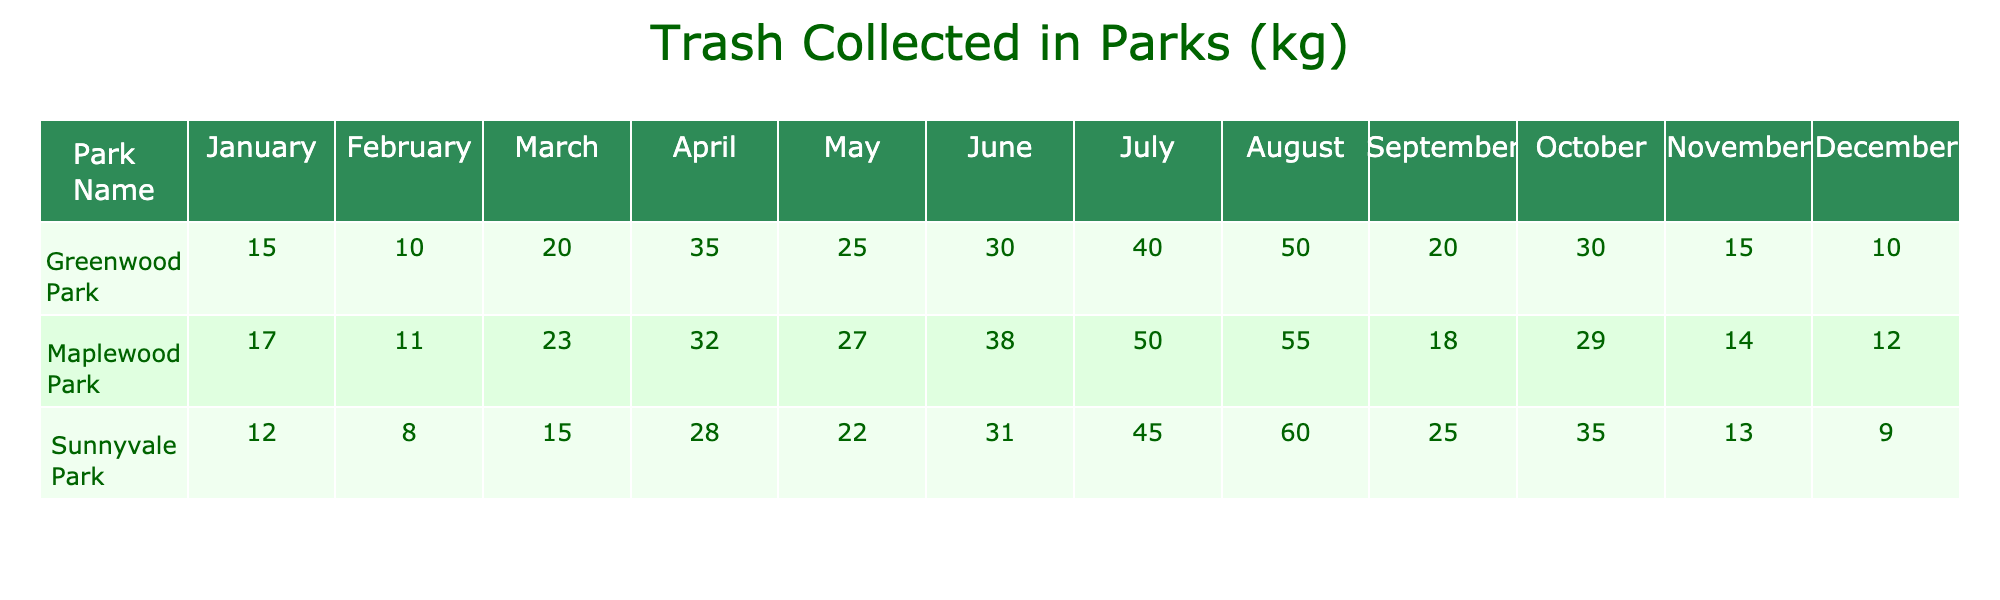What's the total amount of trash collected in Greenwood Park in April? From the table, we can directly see that the trash collected in Greenwood Park in April is 35 kg.
Answer: 35 kg Which park collected the most trash during the year? By looking at the total values of trash collected by each park listed in the table, Sunnyvale Park collected the most trash in total.
Answer: Sunnyvale Park What is the average amount of trash collected in Maplewood Park from January to December? We will sum the values collected each month in Maplewood Park: 17 + 11 + 23 + 32 + 27 + 38 + 50 + 55 + 18 + 29 + 14 + 12 =  336. There are 12 months, so the average is 336 / 12 = 28 kg.
Answer: 28 kg Did Sunnyvale Park ever collect more trash than Greenwood Park in July? Looking at the values in the table, Sunnyvale Park collected 45 kg and Greenwood Park collected 40 kg in July. Since 45 kg is greater than 40 kg, it did collect more trash.
Answer: Yes In which month did Maplewood Park collect the least amount of trash? From the table, we can see the monthly collection values for Maplewood Park. The lowest amount collected is 11 kg in February.
Answer: February 